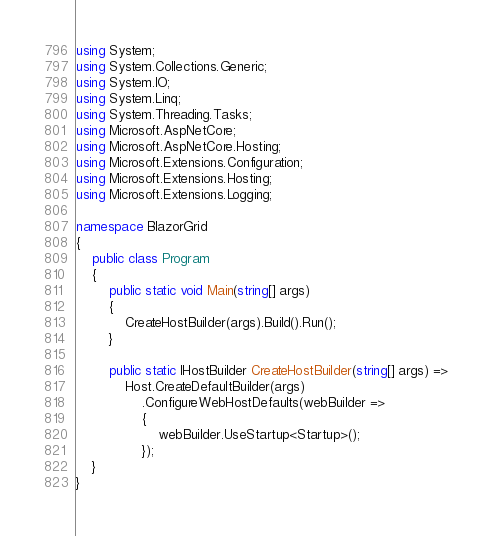<code> <loc_0><loc_0><loc_500><loc_500><_C#_>using System;
using System.Collections.Generic;
using System.IO;
using System.Linq;
using System.Threading.Tasks;
using Microsoft.AspNetCore;
using Microsoft.AspNetCore.Hosting;
using Microsoft.Extensions.Configuration;
using Microsoft.Extensions.Hosting;
using Microsoft.Extensions.Logging;

namespace BlazorGrid
{
    public class Program
    {
        public static void Main(string[] args)
        {
            CreateHostBuilder(args).Build().Run();
        }

        public static IHostBuilder CreateHostBuilder(string[] args) =>
            Host.CreateDefaultBuilder(args)
                .ConfigureWebHostDefaults(webBuilder =>
                {
                    webBuilder.UseStartup<Startup>();
                });
    }
}
</code> 